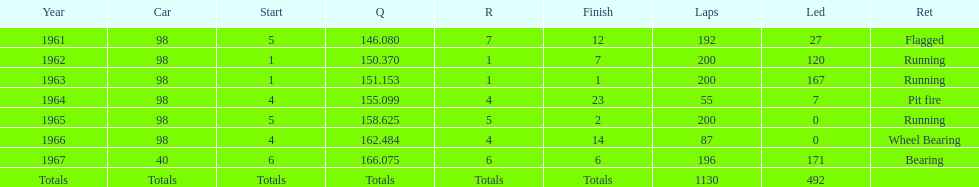What year(s) did parnelli finish at least 4th or better? 1963, 1965. 